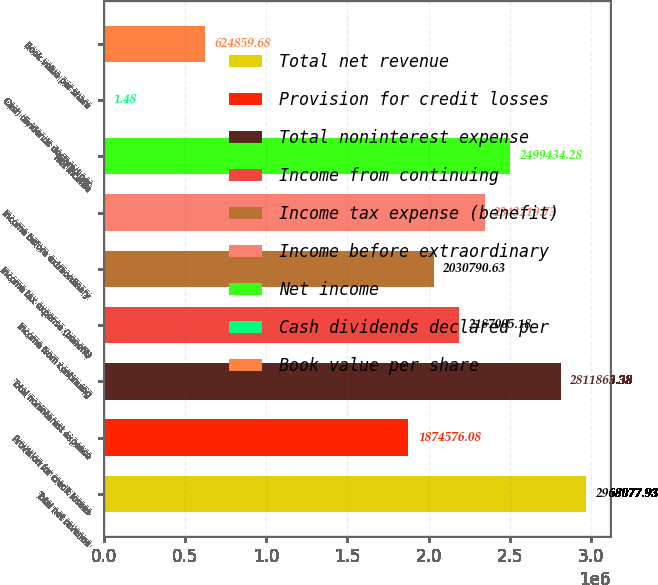Convert chart to OTSL. <chart><loc_0><loc_0><loc_500><loc_500><bar_chart><fcel>Total net revenue<fcel>Provision for credit losses<fcel>Total noninterest expense<fcel>Income from continuing<fcel>Income tax expense (benefit)<fcel>Income before extraordinary<fcel>Net income<fcel>Cash dividends declared per<fcel>Book value per share<nl><fcel>2.96808e+06<fcel>1.87458e+06<fcel>2.81186e+06<fcel>2.18701e+06<fcel>2.03079e+06<fcel>2.34322e+06<fcel>2.49943e+06<fcel>1.48<fcel>624860<nl></chart> 